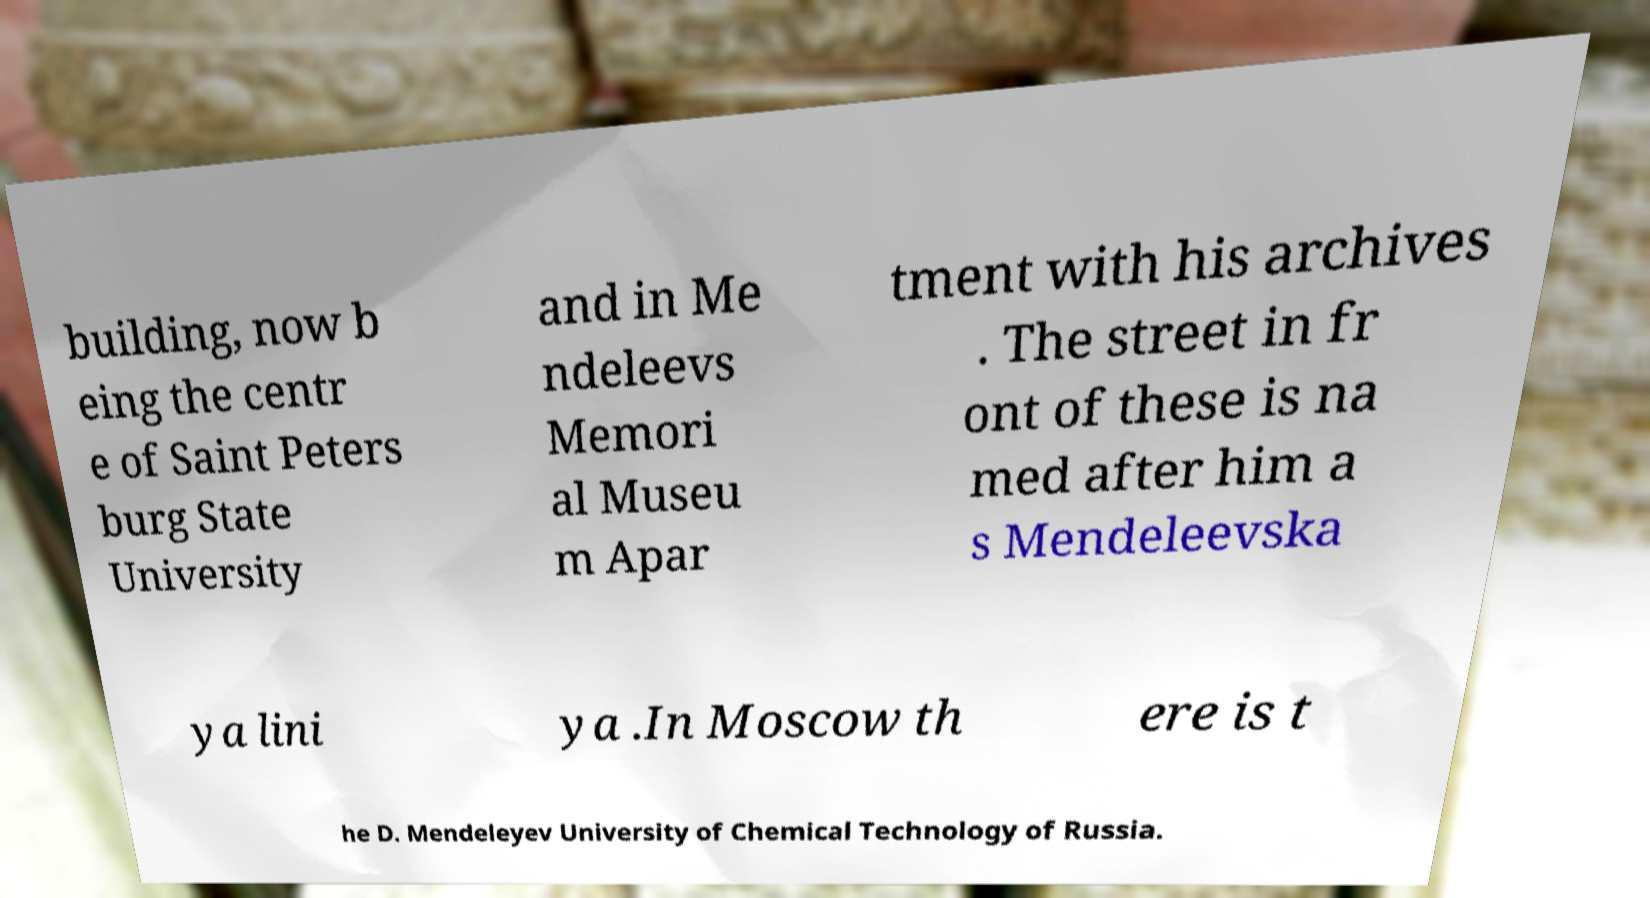I need the written content from this picture converted into text. Can you do that? building, now b eing the centr e of Saint Peters burg State University and in Me ndeleevs Memori al Museu m Apar tment with his archives . The street in fr ont of these is na med after him a s Mendeleevska ya lini ya .In Moscow th ere is t he D. Mendeleyev University of Chemical Technology of Russia. 